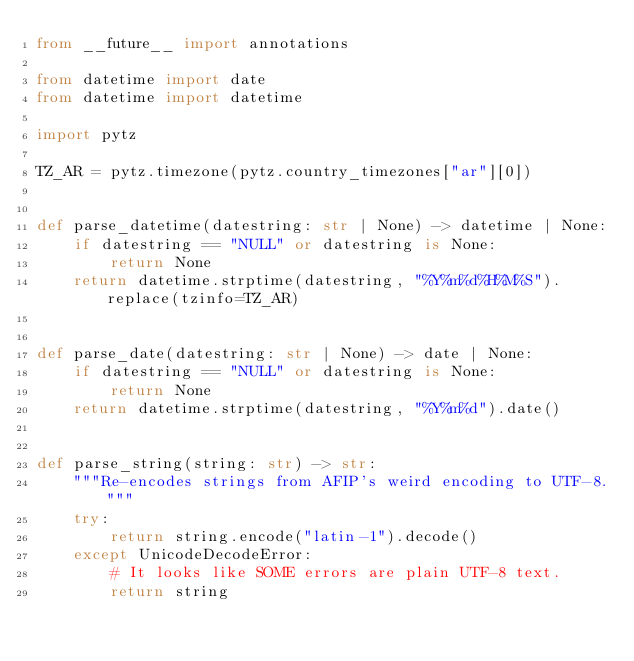Convert code to text. <code><loc_0><loc_0><loc_500><loc_500><_Python_>from __future__ import annotations

from datetime import date
from datetime import datetime

import pytz

TZ_AR = pytz.timezone(pytz.country_timezones["ar"][0])


def parse_datetime(datestring: str | None) -> datetime | None:
    if datestring == "NULL" or datestring is None:
        return None
    return datetime.strptime(datestring, "%Y%m%d%H%M%S").replace(tzinfo=TZ_AR)


def parse_date(datestring: str | None) -> date | None:
    if datestring == "NULL" or datestring is None:
        return None
    return datetime.strptime(datestring, "%Y%m%d").date()


def parse_string(string: str) -> str:
    """Re-encodes strings from AFIP's weird encoding to UTF-8."""
    try:
        return string.encode("latin-1").decode()
    except UnicodeDecodeError:
        # It looks like SOME errors are plain UTF-8 text.
        return string
</code> 